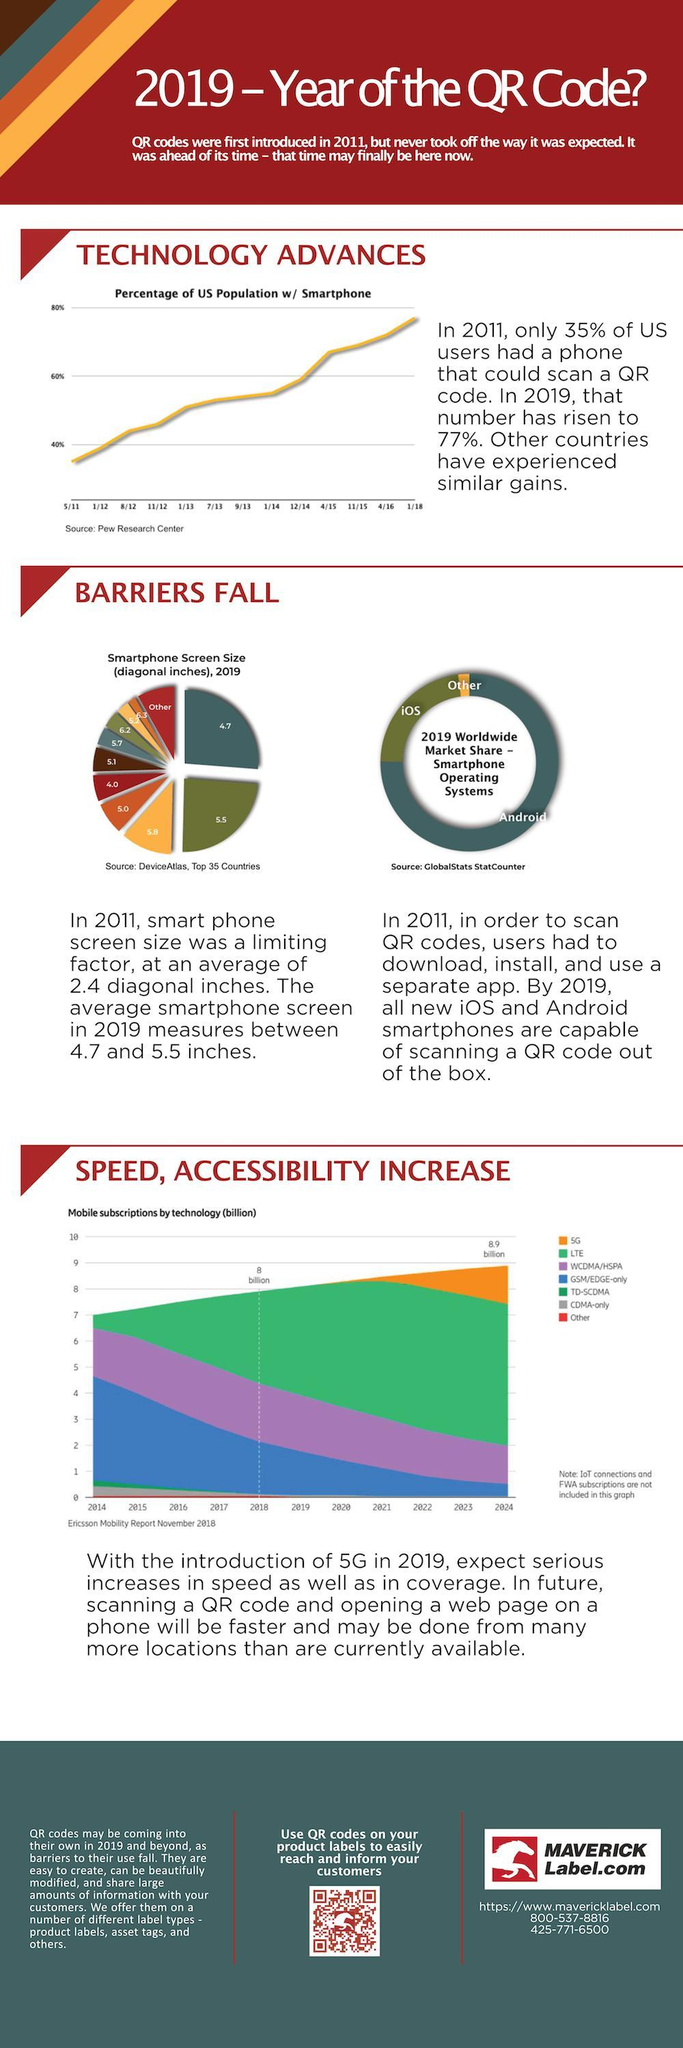What is the percentage of increase of smart phone users from 2011 to 2019 in U.S?
Answer the question with a short phrase. 42 How many types of subscriptions are plotted in the graph? 7 In which color SG is mapped in the graph, red, green, orange or grey? orange Which is the second most used smart phone operating system? iOS Which is the second most widely used smart phone screen size? 5.5 Which is the most used mobile technology? LTE How many subscriptions has LTE reached by 2018? 8 billion 